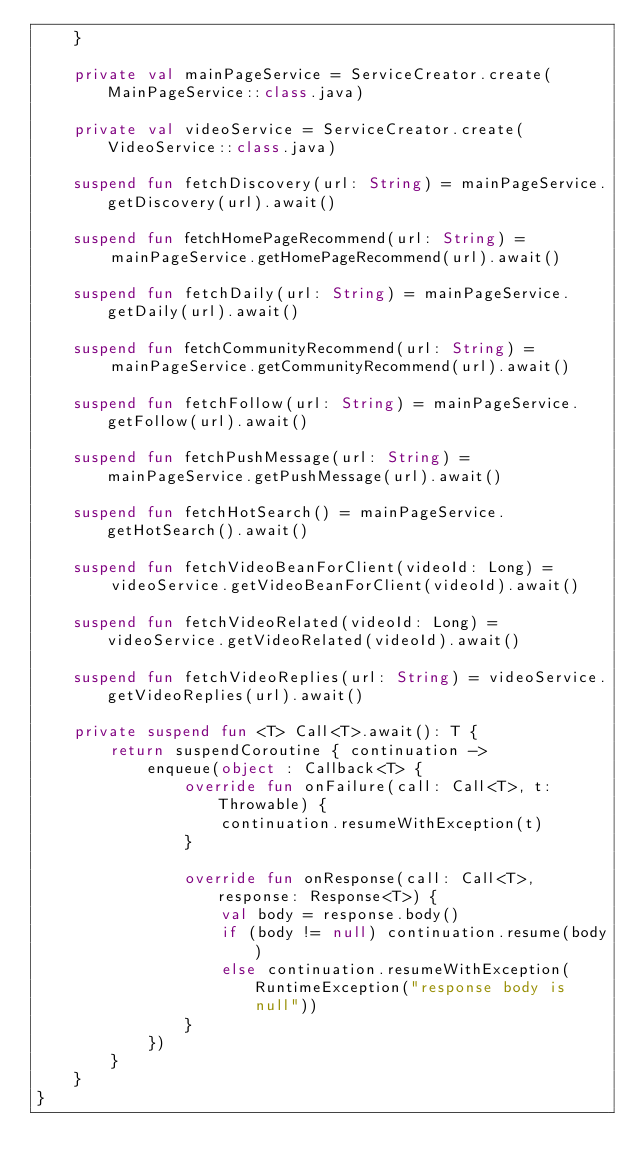<code> <loc_0><loc_0><loc_500><loc_500><_Kotlin_>    }

    private val mainPageService = ServiceCreator.create(MainPageService::class.java)

    private val videoService = ServiceCreator.create(VideoService::class.java)

    suspend fun fetchDiscovery(url: String) = mainPageService.getDiscovery(url).await()

    suspend fun fetchHomePageRecommend(url: String) =
        mainPageService.getHomePageRecommend(url).await()

    suspend fun fetchDaily(url: String) = mainPageService.getDaily(url).await()

    suspend fun fetchCommunityRecommend(url: String) =
        mainPageService.getCommunityRecommend(url).await()

    suspend fun fetchFollow(url: String) = mainPageService.getFollow(url).await()

    suspend fun fetchPushMessage(url: String) = mainPageService.getPushMessage(url).await()

    suspend fun fetchHotSearch() = mainPageService.getHotSearch().await()

    suspend fun fetchVideoBeanForClient(videoId: Long) =
        videoService.getVideoBeanForClient(videoId).await()

    suspend fun fetchVideoRelated(videoId: Long) = videoService.getVideoRelated(videoId).await()

    suspend fun fetchVideoReplies(url: String) = videoService.getVideoReplies(url).await()

    private suspend fun <T> Call<T>.await(): T {
        return suspendCoroutine { continuation ->
            enqueue(object : Callback<T> {
                override fun onFailure(call: Call<T>, t: Throwable) {
                    continuation.resumeWithException(t)
                }

                override fun onResponse(call: Call<T>, response: Response<T>) {
                    val body = response.body()
                    if (body != null) continuation.resume(body)
                    else continuation.resumeWithException(RuntimeException("response body is null"))
                }
            })
        }
    }
}</code> 